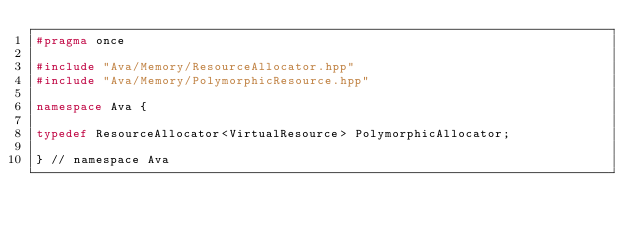<code> <loc_0><loc_0><loc_500><loc_500><_C++_>#pragma once

#include "Ava/Memory/ResourceAllocator.hpp"
#include "Ava/Memory/PolymorphicResource.hpp"

namespace Ava {

typedef ResourceAllocator<VirtualResource> PolymorphicAllocator;

} // namespace Ava
</code> 